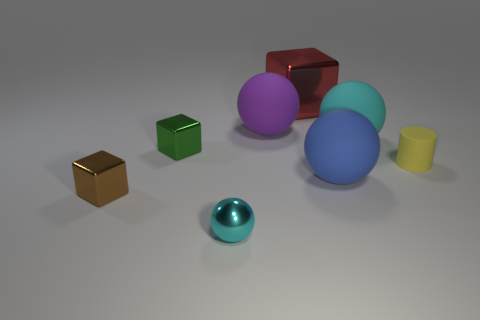The small sphere has what color?
Your answer should be compact. Cyan. What is the size of the red cube that is the same material as the tiny green object?
Your answer should be compact. Large. What number of other matte things have the same shape as the yellow thing?
Make the answer very short. 0. Is there any other thing that has the same size as the yellow thing?
Provide a short and direct response. Yes. How big is the ball right of the large rubber object in front of the green shiny block?
Keep it short and to the point. Large. There is a brown thing that is the same size as the green metal block; what material is it?
Make the answer very short. Metal. Are there any big cubes that have the same material as the purple thing?
Offer a very short reply. No. The shiny block on the right side of the cyan thing in front of the small thing on the left side of the tiny green cube is what color?
Your answer should be compact. Red. Does the shiny cube on the right side of the big purple rubber sphere have the same color as the small rubber cylinder to the right of the purple rubber object?
Ensure brevity in your answer.  No. Is there any other thing that is the same color as the tiny metallic ball?
Make the answer very short. Yes. 